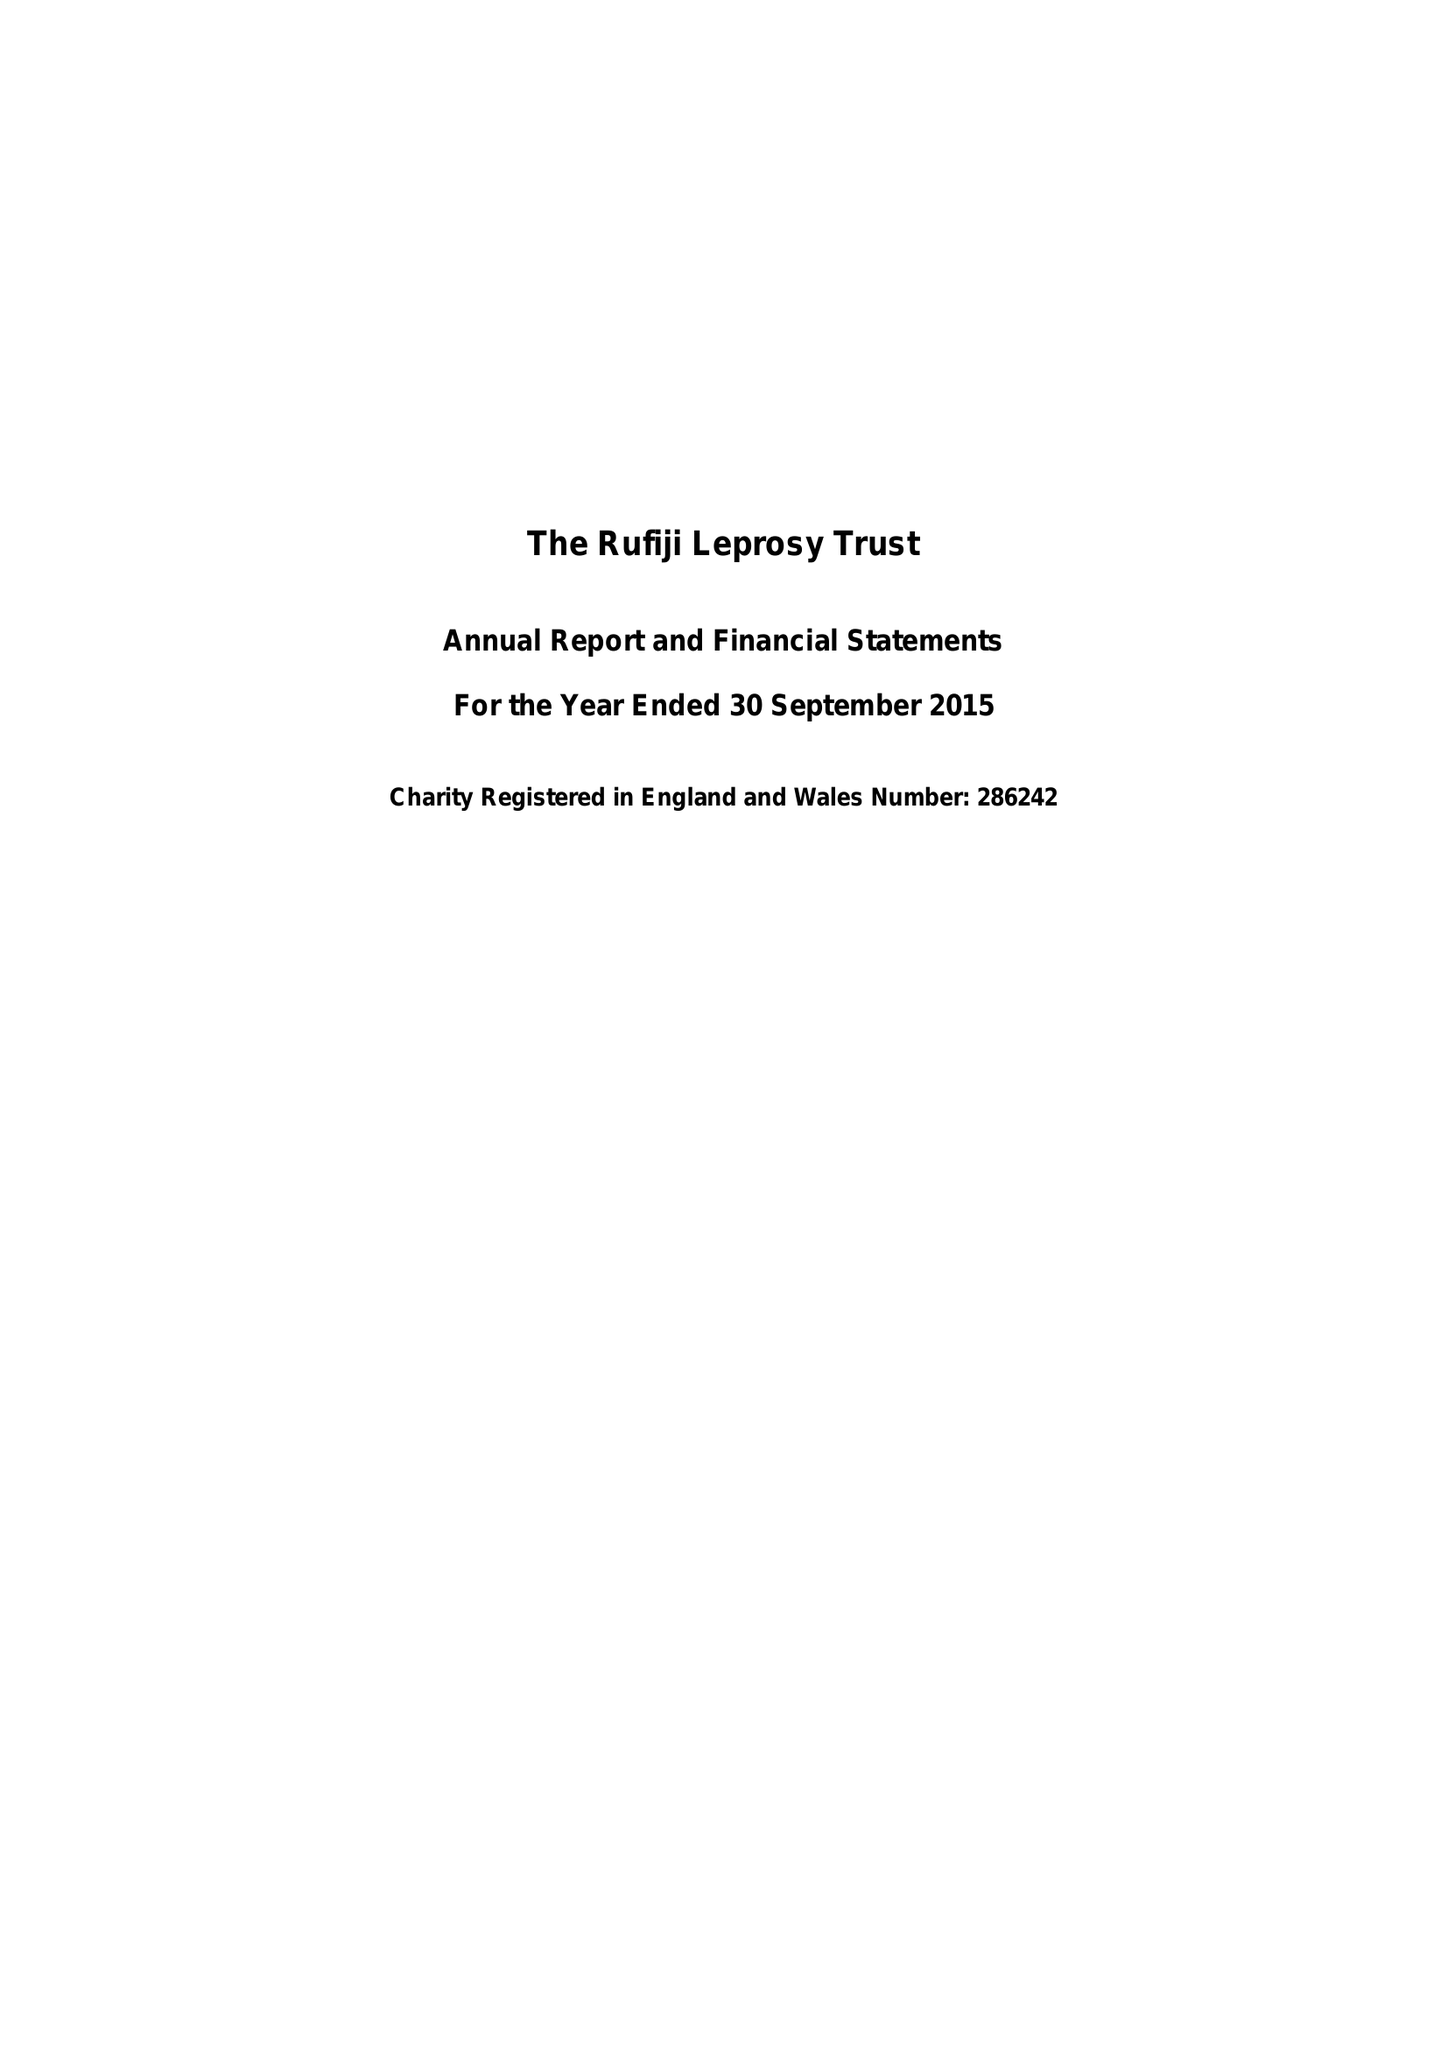What is the value for the income_annually_in_british_pounds?
Answer the question using a single word or phrase. 27572.00 